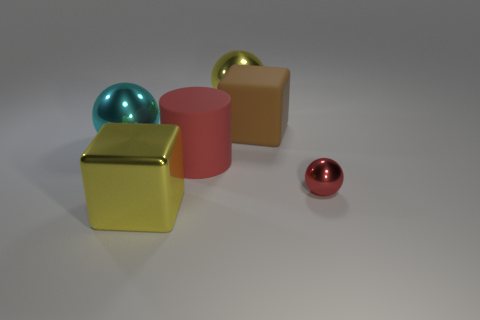Add 3 large brown things. How many objects exist? 9 Subtract all cylinders. How many objects are left? 5 Subtract all big rubber cylinders. Subtract all big yellow metallic cubes. How many objects are left? 4 Add 4 tiny red metal balls. How many tiny red metal balls are left? 5 Add 3 big shiny balls. How many big shiny balls exist? 5 Subtract 0 purple cubes. How many objects are left? 6 